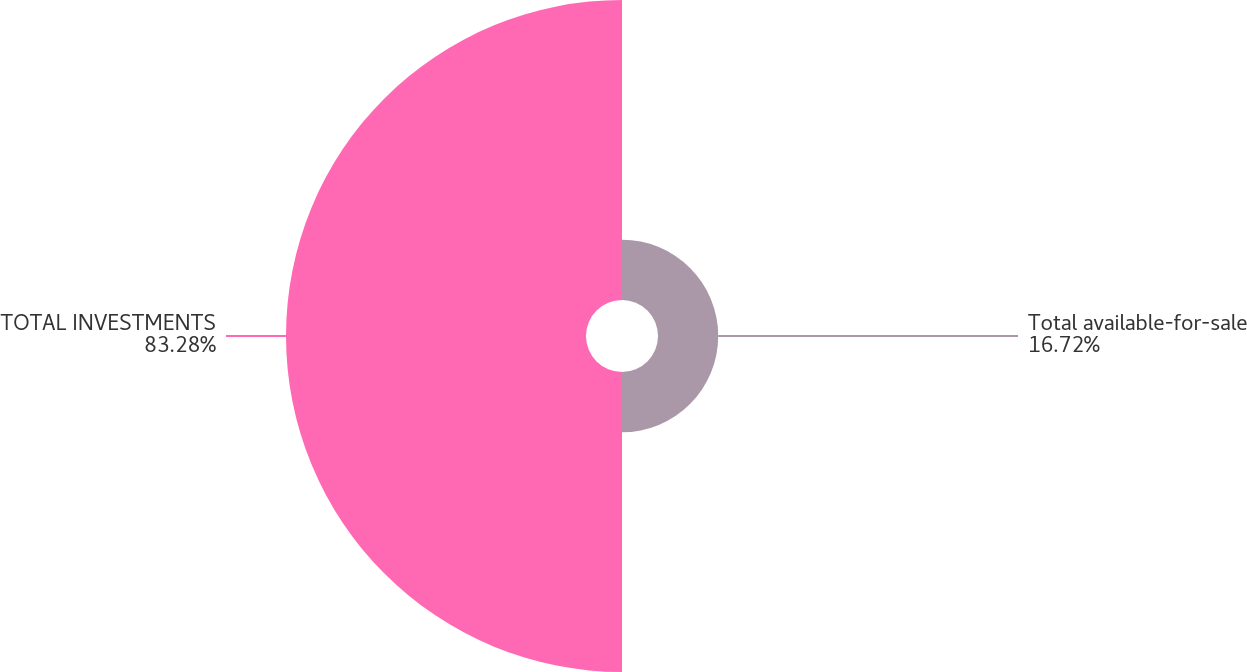<chart> <loc_0><loc_0><loc_500><loc_500><pie_chart><fcel>Total available-for-sale<fcel>TOTAL INVESTMENTS<nl><fcel>16.72%<fcel>83.28%<nl></chart> 